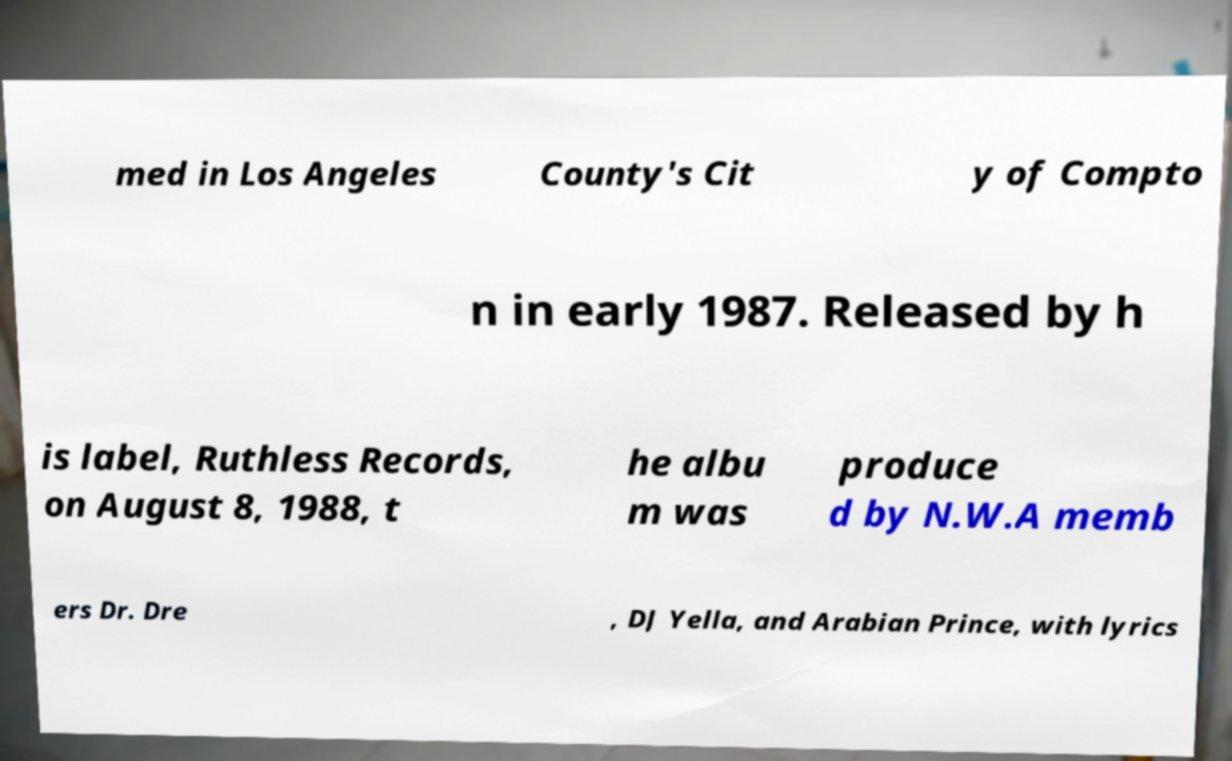Could you extract and type out the text from this image? med in Los Angeles County's Cit y of Compto n in early 1987. Released by h is label, Ruthless Records, on August 8, 1988, t he albu m was produce d by N.W.A memb ers Dr. Dre , DJ Yella, and Arabian Prince, with lyrics 